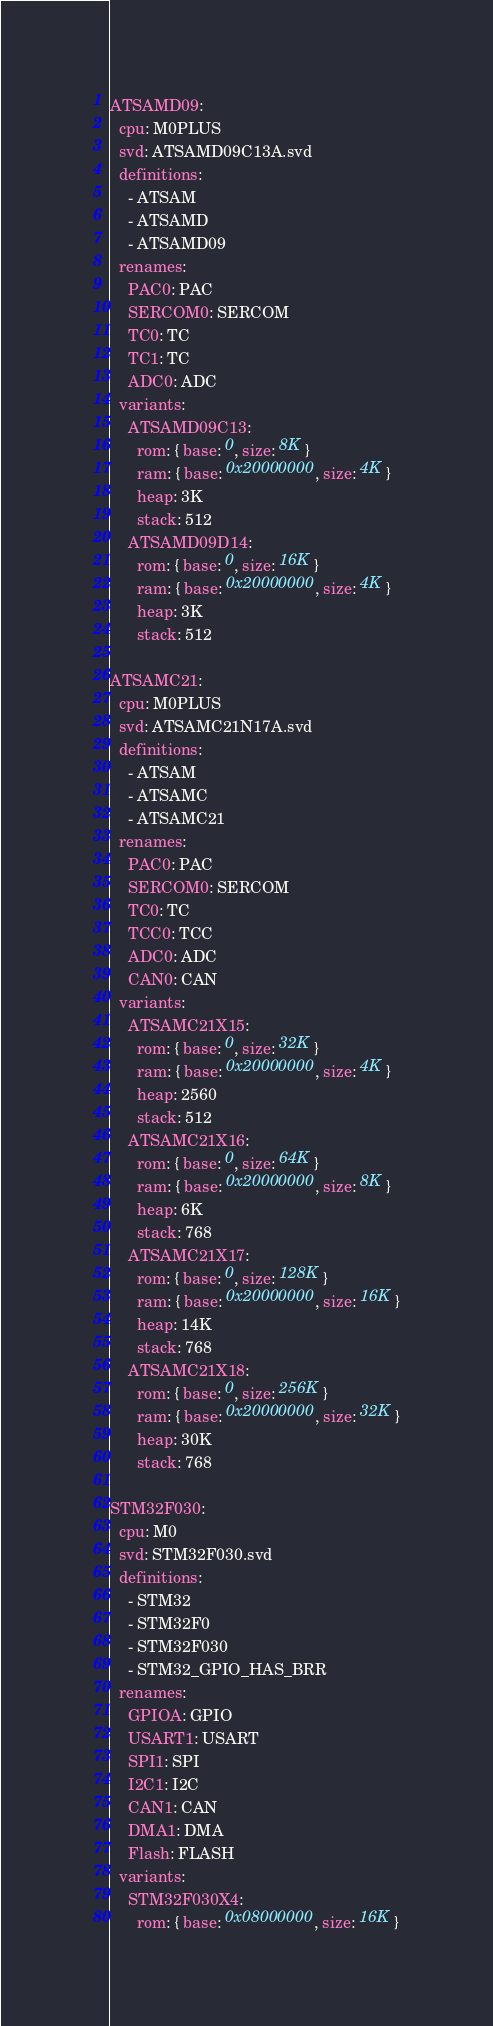<code> <loc_0><loc_0><loc_500><loc_500><_YAML_>ATSAMD09:
  cpu: M0PLUS
  svd: ATSAMD09C13A.svd
  definitions:
    - ATSAM
    - ATSAMD
    - ATSAMD09
  renames:
    PAC0: PAC
    SERCOM0: SERCOM
    TC0: TC
    TC1: TC
    ADC0: ADC
  variants:
    ATSAMD09C13:
      rom: { base: 0, size: 8K }
      ram: { base: 0x20000000, size: 4K }
      heap: 3K
      stack: 512
    ATSAMD09D14:
      rom: { base: 0, size: 16K }
      ram: { base: 0x20000000, size: 4K }
      heap: 3K
      stack: 512

ATSAMC21:
  cpu: M0PLUS
  svd: ATSAMC21N17A.svd
  definitions:
    - ATSAM
    - ATSAMC
    - ATSAMC21
  renames:
    PAC0: PAC
    SERCOM0: SERCOM
    TC0: TC
    TCC0: TCC
    ADC0: ADC
    CAN0: CAN
  variants:
    ATSAMC21X15:
      rom: { base: 0, size: 32K }
      ram: { base: 0x20000000, size: 4K }
      heap: 2560
      stack: 512
    ATSAMC21X16:
      rom: { base: 0, size: 64K }
      ram: { base: 0x20000000, size: 8K }
      heap: 6K
      stack: 768
    ATSAMC21X17:
      rom: { base: 0, size: 128K }
      ram: { base: 0x20000000, size: 16K }
      heap: 14K
      stack: 768
    ATSAMC21X18:
      rom: { base: 0, size: 256K }
      ram: { base: 0x20000000, size: 32K }
      heap: 30K
      stack: 768

STM32F030:
  cpu: M0
  svd: STM32F030.svd
  definitions:
    - STM32
    - STM32F0
    - STM32F030
    - STM32_GPIO_HAS_BRR
  renames:
    GPIOA: GPIO
    USART1: USART
    SPI1: SPI
    I2C1: I2C
    CAN1: CAN
    DMA1: DMA
    Flash: FLASH
  variants:
    STM32F030X4:
      rom: { base: 0x08000000, size: 16K }</code> 